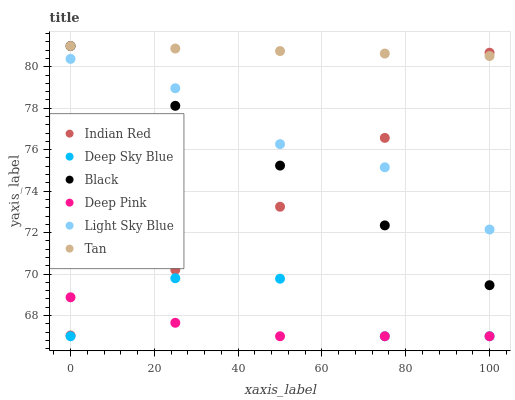Does Deep Pink have the minimum area under the curve?
Answer yes or no. Yes. Does Tan have the maximum area under the curve?
Answer yes or no. Yes. Does Indian Red have the minimum area under the curve?
Answer yes or no. No. Does Indian Red have the maximum area under the curve?
Answer yes or no. No. Is Tan the smoothest?
Answer yes or no. Yes. Is Deep Sky Blue the roughest?
Answer yes or no. Yes. Is Indian Red the smoothest?
Answer yes or no. No. Is Indian Red the roughest?
Answer yes or no. No. Does Deep Pink have the lowest value?
Answer yes or no. Yes. Does Indian Red have the lowest value?
Answer yes or no. No. Does Tan have the highest value?
Answer yes or no. Yes. Does Indian Red have the highest value?
Answer yes or no. No. Is Deep Sky Blue less than Indian Red?
Answer yes or no. Yes. Is Light Sky Blue greater than Deep Sky Blue?
Answer yes or no. Yes. Does Black intersect Indian Red?
Answer yes or no. Yes. Is Black less than Indian Red?
Answer yes or no. No. Is Black greater than Indian Red?
Answer yes or no. No. Does Deep Sky Blue intersect Indian Red?
Answer yes or no. No. 